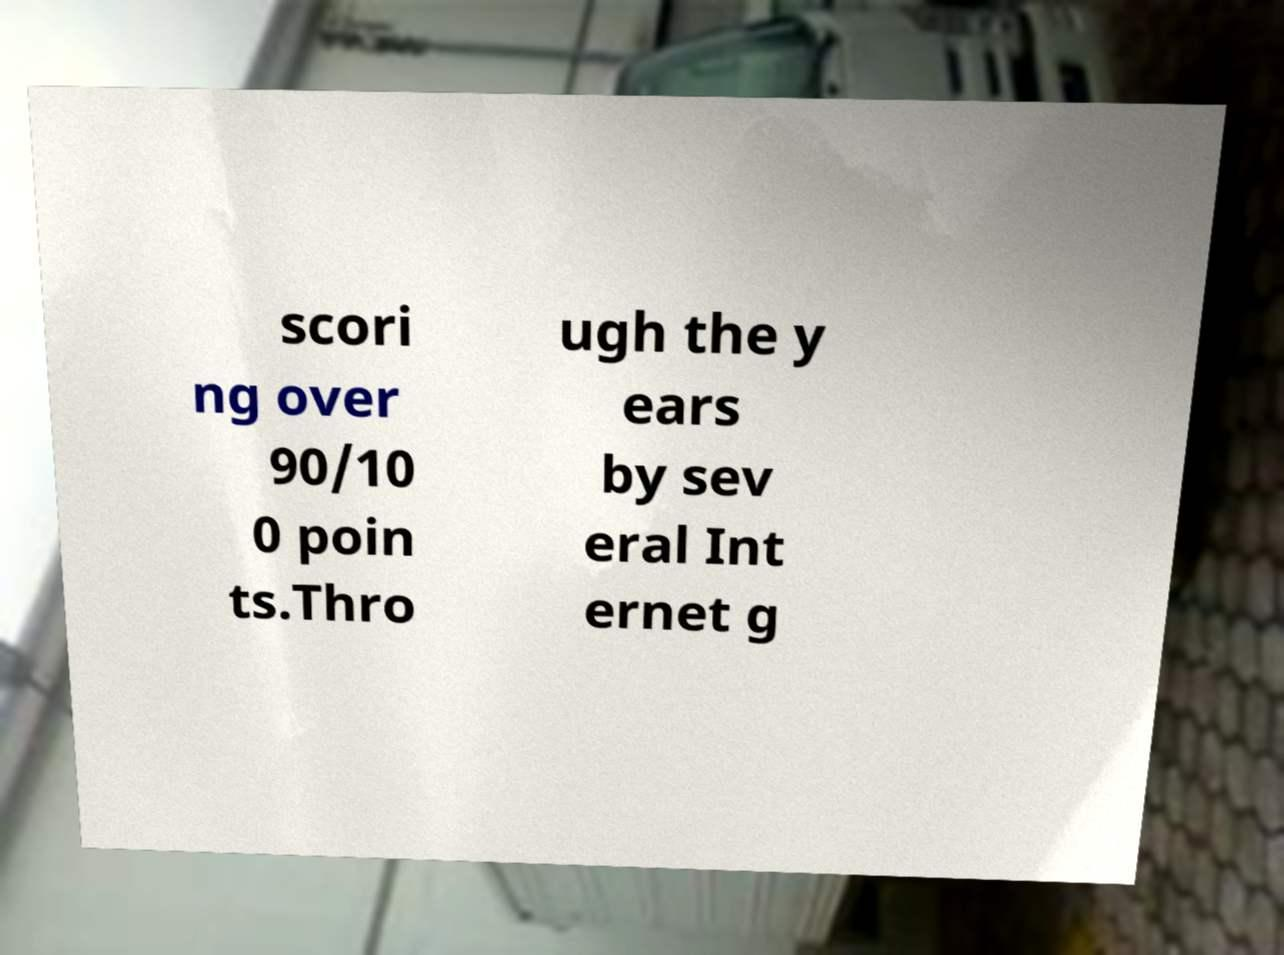What messages or text are displayed in this image? I need them in a readable, typed format. scori ng over 90/10 0 poin ts.Thro ugh the y ears by sev eral Int ernet g 